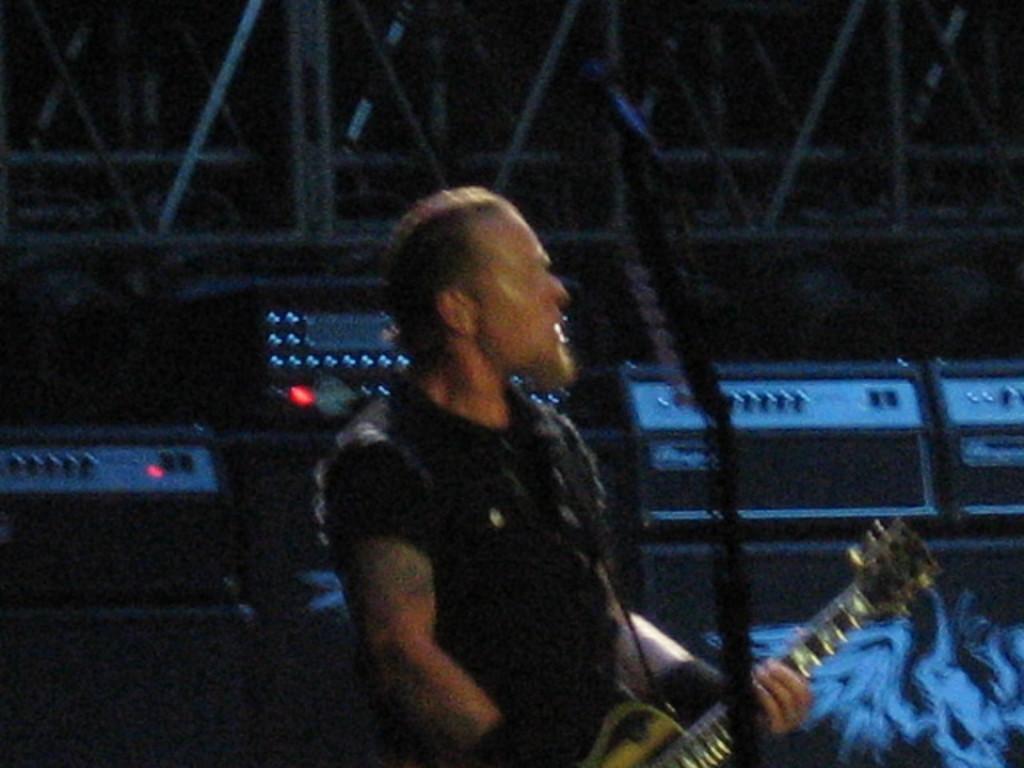Can you describe this image briefly? In this image I can see a person holding a guitar. 